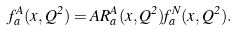Convert formula to latex. <formula><loc_0><loc_0><loc_500><loc_500>f _ { a } ^ { A } ( x , Q ^ { 2 } ) = A R _ { a } ^ { A } ( x , Q ^ { 2 } ) f _ { a } ^ { N } ( x , Q ^ { 2 } ) .</formula> 